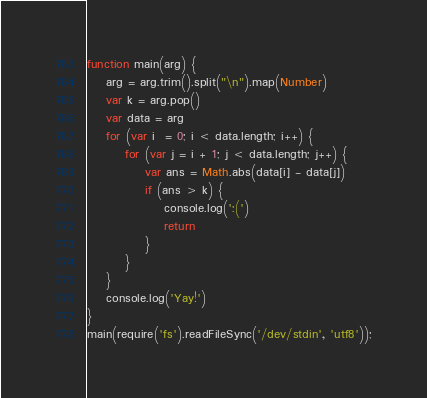Convert code to text. <code><loc_0><loc_0><loc_500><loc_500><_JavaScript_>function main(arg) {
	arg = arg.trim().split("\n").map(Number)
	var k = arg.pop()
	var data = arg
	for (var i  = 0; i < data.length; i++) {
		for (var j = i + 1; j < data.length; j++) {
			var ans = Math.abs(data[i] - data[j])
			if (ans > k) {
				console.log(':(')
				return
			}
		}
	}
	console.log('Yay!')
}
main(require('fs').readFileSync('/dev/stdin', 'utf8'));
</code> 